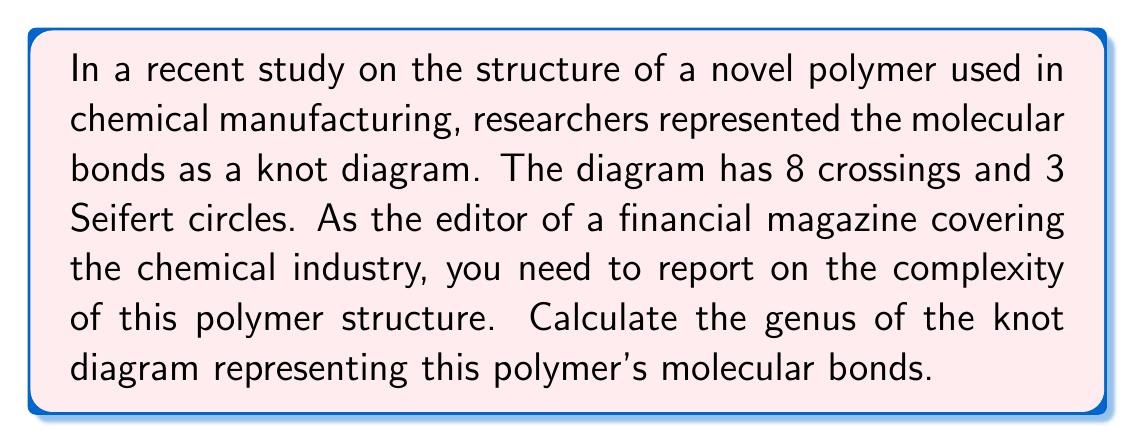Solve this math problem. To calculate the genus of a knot diagram, we'll follow these steps:

1) Recall the formula for the genus of a knot diagram:
   $$ g = \frac{1}{2}(c - s + 1) $$
   where $g$ is the genus, $c$ is the number of crossings, and $s$ is the number of Seifert circles.

2) We're given:
   - Number of crossings, $c = 8$
   - Number of Seifert circles, $s = 3$

3) Let's substitute these values into the formula:
   $$ g = \frac{1}{2}(8 - 3 + 1) $$

4) Simplify inside the parentheses:
   $$ g = \frac{1}{2}(6) $$

5) Calculate the final result:
   $$ g = 3 $$

Therefore, the genus of the knot diagram representing the polymer's molecular bonds is 3.

This value indicates the complexity of the polymer structure, which could be relevant for manufacturing processes and potentially impact production costs in the chemical industry.
Answer: $3$ 